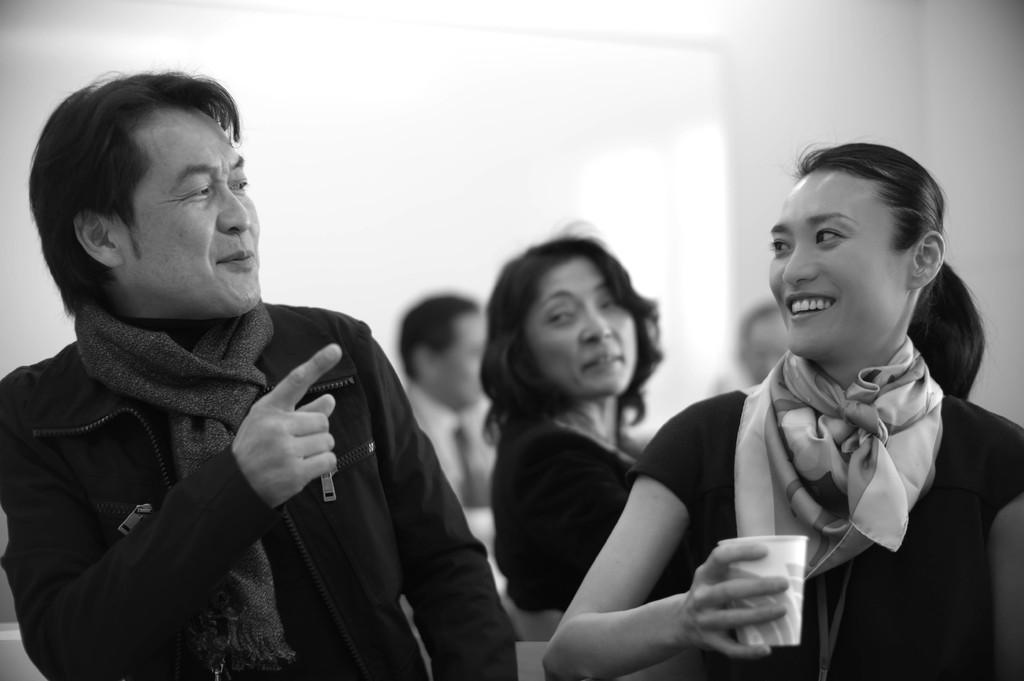Who is present in the image? There is a woman and a man in the image. What is the woman doing in the image? The woman is standing and smiling. How is the man positioned in relation to the woman? The man is standing beside the woman. What is the color of the background in the image? The background of the image is white. What type of chain is the woman holding in the image? There is no chain present in the image. How does the man grip the woman's hand in the image? There is no indication that the man is holding the woman's hand in the image. 